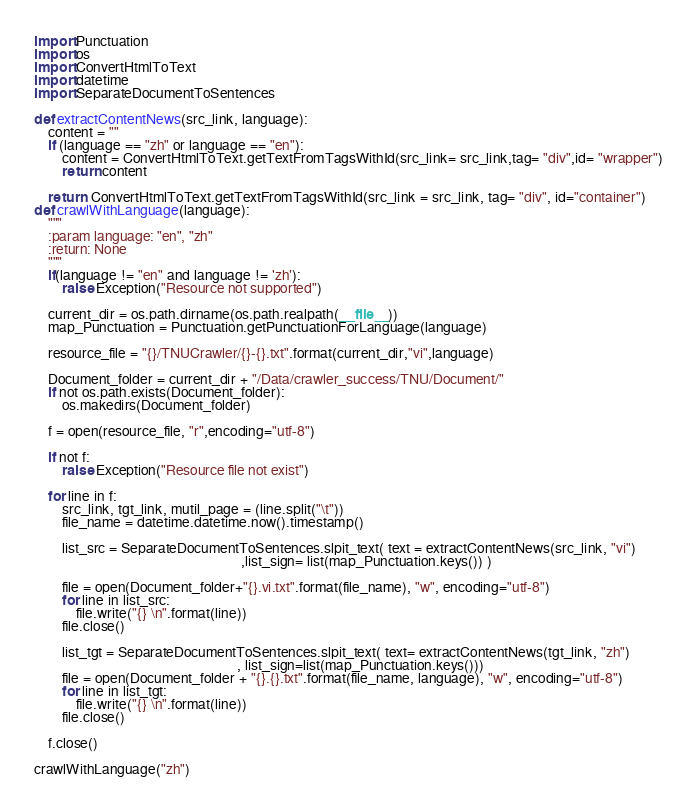Convert code to text. <code><loc_0><loc_0><loc_500><loc_500><_Python_>import Punctuation
import os
import ConvertHtmlToText
import datetime
import SeparateDocumentToSentences

def extractContentNews(src_link, language):
    content = ""
    if (language == "zh" or language == "en"):
        content = ConvertHtmlToText.getTextFromTagsWithId(src_link= src_link,tag= "div",id= "wrapper")
        return content

    return  ConvertHtmlToText.getTextFromTagsWithId(src_link = src_link, tag= "div", id="container")
def crawlWithLanguage(language):
    """
    :param language: "en", "zh"
    :return: None
    """
    if(language != "en" and language != 'zh'):
        raise Exception("Resource not supported")

    current_dir = os.path.dirname(os.path.realpath(__file__))
    map_Punctuation = Punctuation.getPunctuationForLanguage(language)

    resource_file = "{}/TNUCrawler/{}-{}.txt".format(current_dir,"vi",language)

    Document_folder = current_dir + "/Data/crawler_success/TNU/Document/"
    if not os.path.exists(Document_folder):
        os.makedirs(Document_folder)

    f = open(resource_file, "r",encoding="utf-8")

    if not f:
        raise Exception("Resource file not exist")

    for line in f:
        src_link, tgt_link, mutil_page = (line.split("\t"))
        file_name = datetime.datetime.now().timestamp()

        list_src = SeparateDocumentToSentences.slpit_text( text = extractContentNews(src_link, "vi")
                                                           ,list_sign= list(map_Punctuation.keys()) )

        file = open(Document_folder+"{}.vi.txt".format(file_name), "w", encoding="utf-8")
        for line in list_src:
            file.write("{} \n".format(line))
        file.close()

        list_tgt = SeparateDocumentToSentences.slpit_text( text= extractContentNews(tgt_link, "zh")
                                                          , list_sign=list(map_Punctuation.keys()))
        file = open(Document_folder + "{}.{}.txt".format(file_name, language), "w", encoding="utf-8")
        for line in list_tgt:
            file.write("{} \n".format(line))
        file.close()

    f.close()

crawlWithLanguage("zh")</code> 